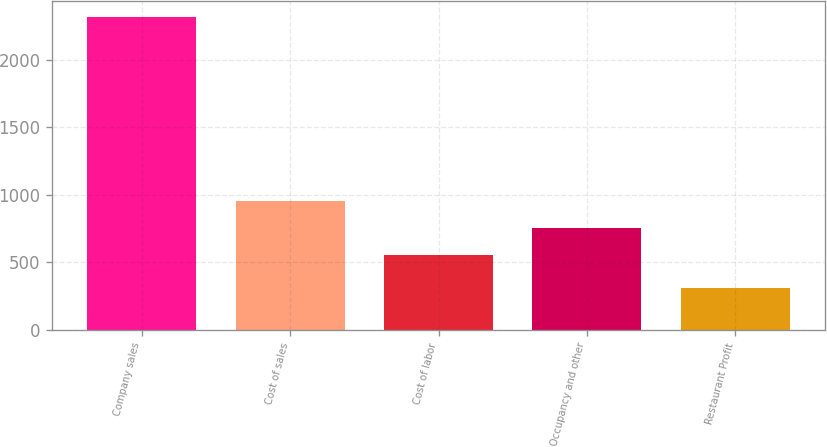Convert chart to OTSL. <chart><loc_0><loc_0><loc_500><loc_500><bar_chart><fcel>Company sales<fcel>Cost of sales<fcel>Cost of labor<fcel>Occupancy and other<fcel>Restaurant Profit<nl><fcel>2320<fcel>954.4<fcel>552<fcel>753.2<fcel>308<nl></chart> 